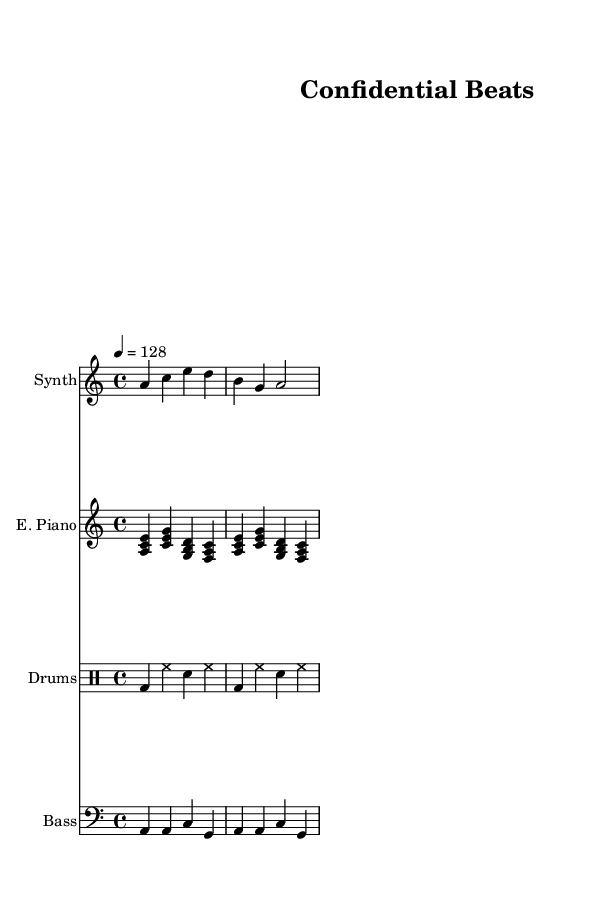What is the key signature of this music? The key signature shows sharp or flat symbols at the beginning of the staff lines, indicating the key. Here, it is indicated as 'a minor', which means there are no sharps or flats (relative to C major).
Answer: A minor What is the time signature of this music? The time signature can be found at the beginning of the music section, represented by two numbers stacked vertically. This score has a time signature of 4/4, meaning there are four beats in a measure.
Answer: 4/4 What is the tempo of this piece? The tempo is given in beats per minute (BPM) and is found near the beginning of the score. In this case, it is indicated as '4 = 128', meaning there are 128 beats per minute.
Answer: 128 How many measures are there in the synth melody? By counting the bars or vertical lines separating the groups of notes in the synth melody, you can see there are a total of two measures.
Answer: 2 What instruments are featured in this score? The instruments used are indicated at the beginning of each staff. They include Synth, Electric Piano, Drums, and Bass.
Answer: Synth, Electric Piano, Drums, Bass What is the main rhythmic element of the drum machine part? The drum machine part displays a consistent pattern of bass drum (bd), hi-hat (hh), and snare (sn) in its measures, a typical characteristic of house music rhythms. The main rhythmic element is a four-beat structure.
Answer: Four-beat structure What characteristic of house music does the bass synth part illustrate? The bass synth section features repetitive bass lines with an emphasis on the root note a, typical for house music, providing a solid foundation and groove. This emphasizes the rhythmic structure and keeps listeners engaged.
Answer: Repetitive bass lines 